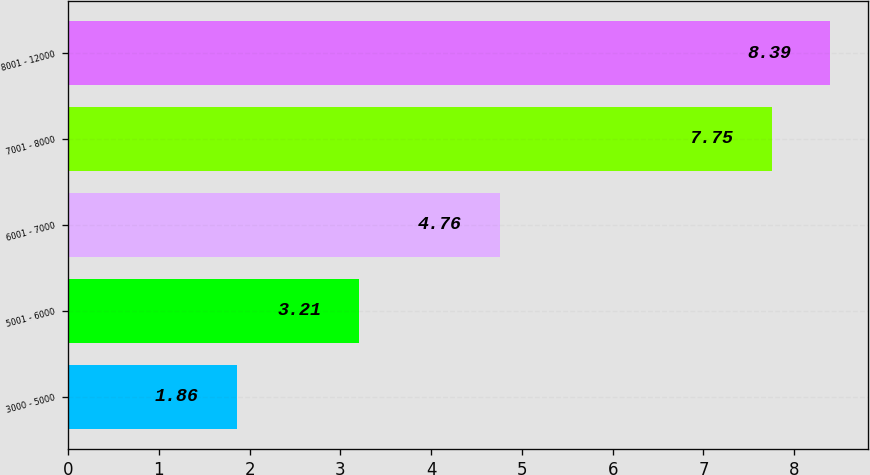Convert chart to OTSL. <chart><loc_0><loc_0><loc_500><loc_500><bar_chart><fcel>3000 - 5000<fcel>5001 - 6000<fcel>6001 - 7000<fcel>7001 - 8000<fcel>8001 - 12000<nl><fcel>1.86<fcel>3.21<fcel>4.76<fcel>7.75<fcel>8.39<nl></chart> 